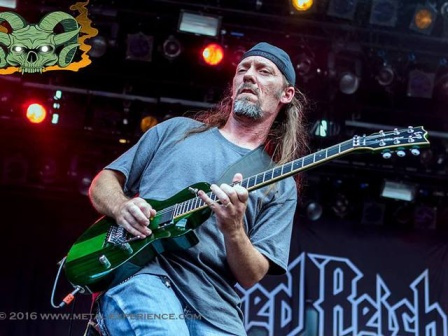What's unique about this guitar? This guitar stands out with its vibrant green color, which is not commonly seen in standard designs, suggesting a custom or special edition model. The unique color could reflect the musician’s individuality and desire to make a bold statement on stage. Additionally, the electric guitar's build and design might be tailored to produce specific tones that complement the musician's style. Based on the image, describe the potential sound of the music being played. Given the visual cues—such as the intense focus of the musician, the black bandana, and the green skull graphic—the music likely has a hard-edged, vigorous rock or metal sound. The energetic performance suggests powerful guitar riffs, possibly combined with fast-paced, dynamic rhythms and compelling vocal lines. The band's name, 'Red Beach', might hint at themes of rebellion, vitality, and raw emotional expression in their music. Create a wild, imaginative scenario involving this musician. An intergalactic rockstar, this musician travels from planet to planet, spreading the universal language of music. Equipped with his green guitar, which doubles as a cosmic instrument capable of producing sounds from alien civilizations, he unites diverse beings through electrifying performances. The green skull emblem is not just a decorative piece but a symbol of his alliance with an ancient extraterrestrial race that entrusted him with the mission of fostering harmony across the universe through the power of rock music. Imagine if his guitar could speak, what would it say about their travels? “We’ve seen it all—from the neon-lit asteroid bars in the Andromeda Galaxy to the serene, moonlit concerts on Europa. My strings have resonated with the harmonies of countless worlds, each note a bridge between distant stars. Together, we’ve faced cosmic storms and played before audiences of ethereal beings. Every strum tells a story, every riff a memory etched in the fabric of the cosmos. The journey continues, and with every performance, we bring a little more connectedness to the universe.”  Can you describe the musician's energy and presence on stage in a very detailed way? On stage, the musician exudes a magnetic presence that captures the audience's attention instantly. His movements are fluid yet precise, every gesture purposeful and in harmony with the music. His face, a canvas of raw emotion, reflects the intensity of each note he plays on his green guitar. The black bandana keeps his long hair in check, preventing it from obscuring his focused, almost fierce, expression.

As he delves into a solo, his fingers dance across the fretboard with unwavering precision, each note resonating with passion and skill. The stage lights cast dramatic shadows, highlighting his form and amplifying the dynamic energy that pulses through him. His casual attire contrasts sharply with the depth of his performance, emphasizing that true showmanship is not in flashy clothes but in the emotion and energy conveyed through the music.

The green skull graphic near the left side of the stage seems almost alive, its eerie grin a visual echo of the powerful sound waves emanating from the guitar. The audience, visible in glimpses behind the stage lights, is entranced, swaying and moving in unison, caught in the spell of his performance. Each chord he strikes reverberates not just through the air but through the collective consciousness of the crowd, creating a shared experience of pure, unadulterated rock energy. 